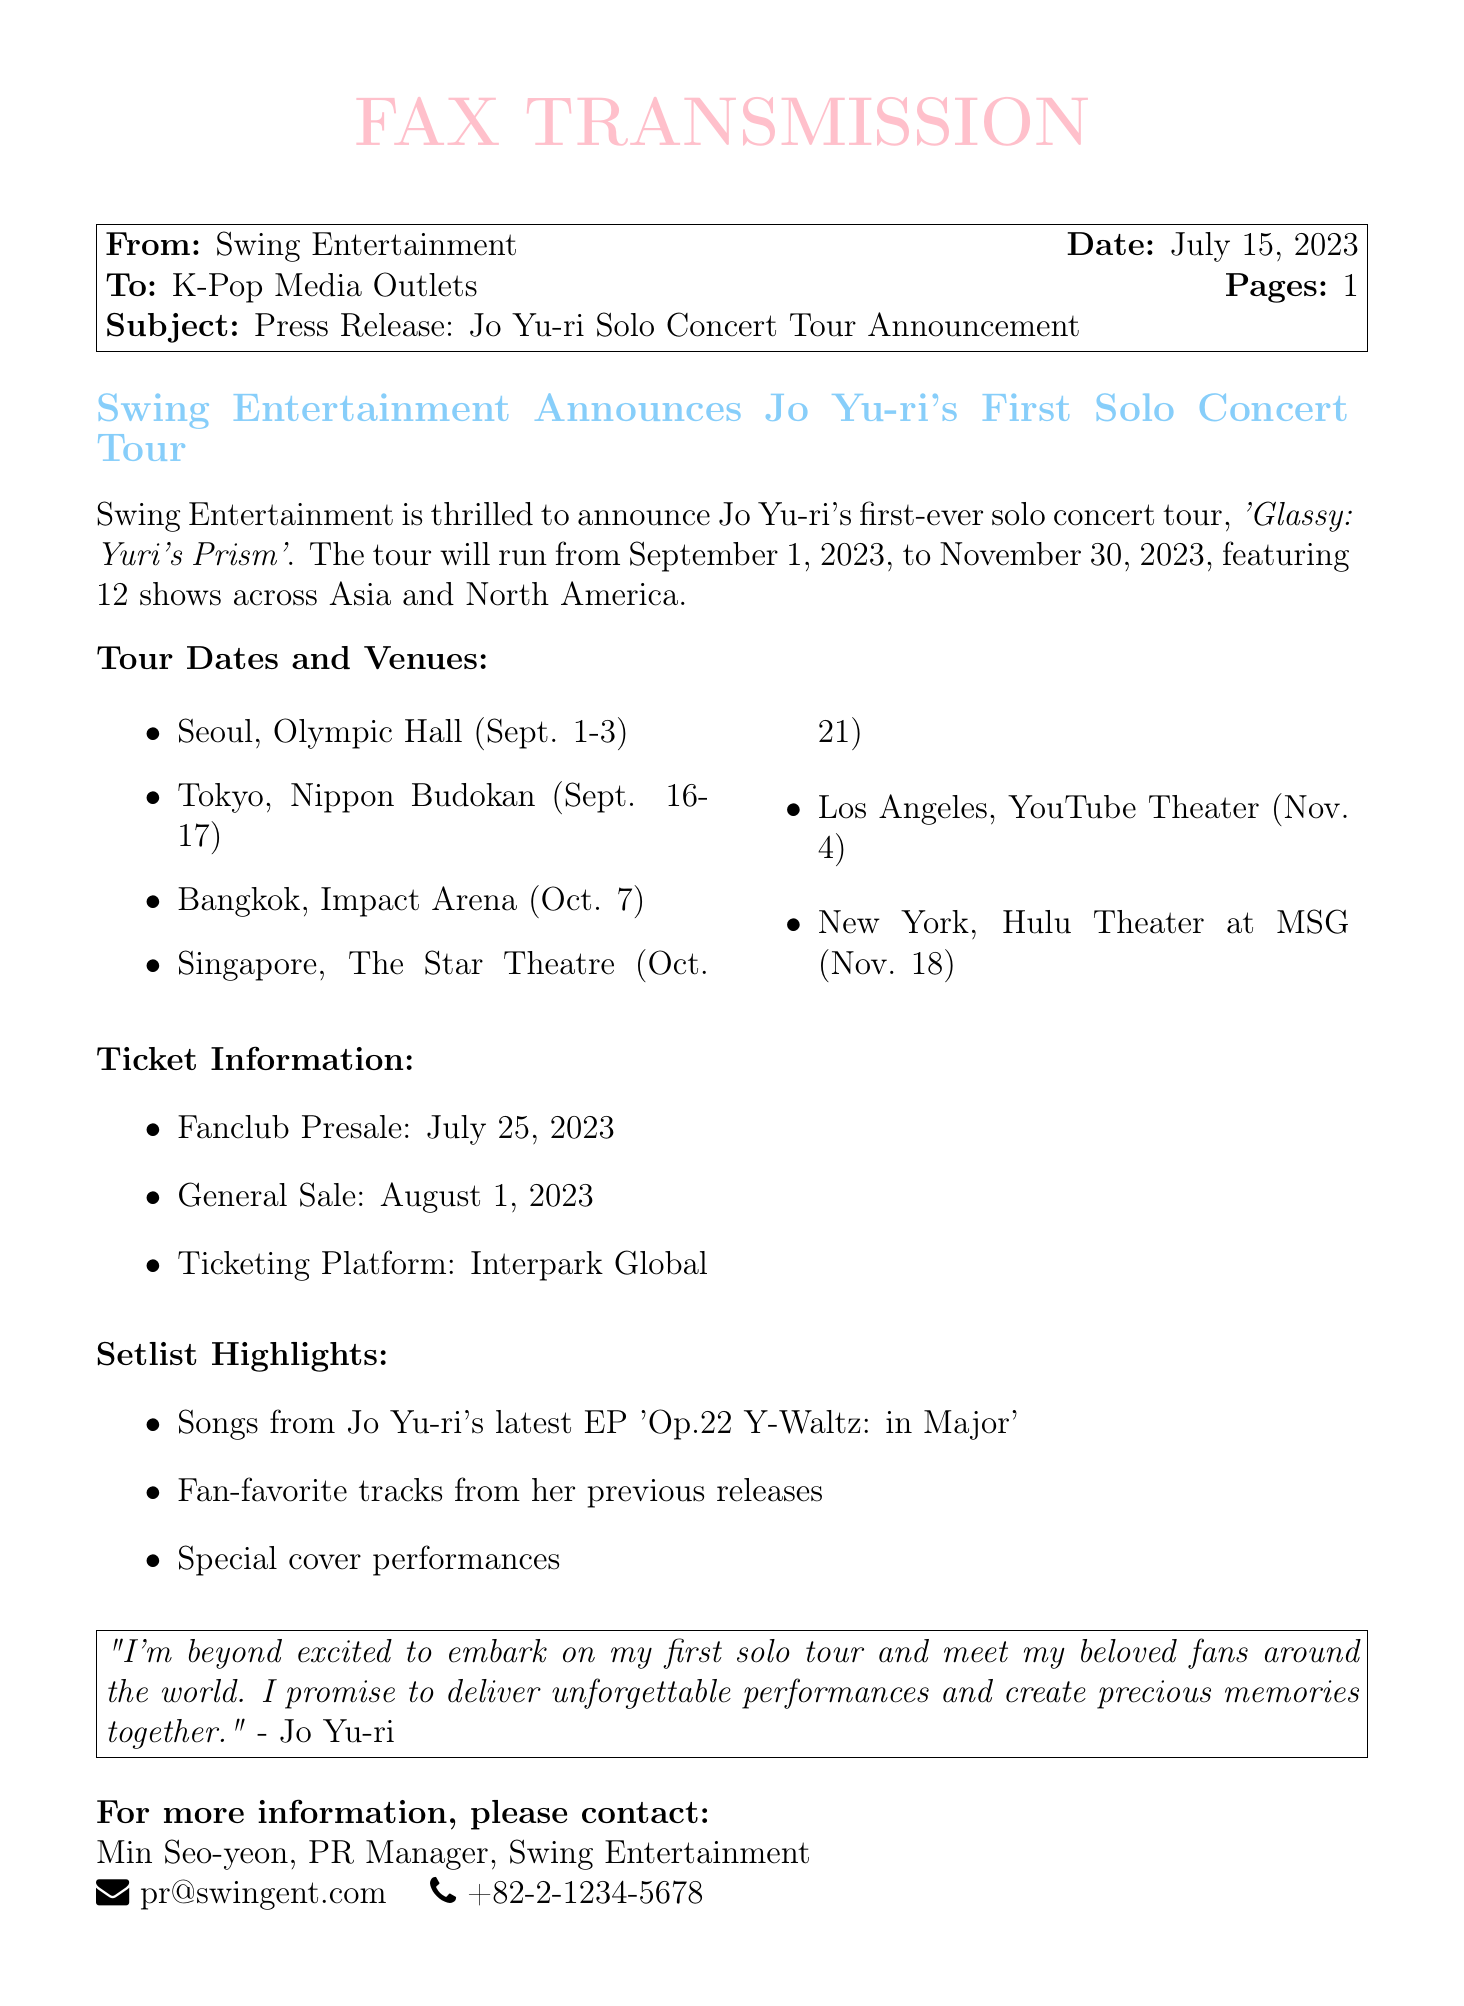What is the name of the concert tour? The document specifies that the concert tour is titled 'Glassy: Yuri's Prism'.
Answer: 'Glassy: Yuri's Prism' When does the tour start? The tour is set to begin on September 1, 2023, as stated in the document.
Answer: September 1, 2023 How many shows will be held during the tour? The document mentions that there will be a total of 12 shows across Asia and North America.
Answer: 12 What is the venue for the Seoul concert? The document states that the Seoul concerts will take place at Olympic Hall.
Answer: Olympic Hall What date will tickets go on general sale? According to the document, general sale will begin on August 1, 2023.
Answer: August 1, 2023 Who is the PR Manager for Swing Entertainment? The document identifies Min Seo-yeon as the PR Manager.
Answer: Min Seo-yeon What is included in the setlist highlights? The highlights mention songs from Jo Yu-ri's latest EP, fan-favorite tracks, and special cover performances.
Answer: Songs from Jo Yu-ri's latest EP 'Op.22 Y-Waltz: in Major', fan-favorite tracks, special cover performances How many days will the concerts in Tokyo take place? The document states that the Tokyo concerts will occur over two days, September 16-17, 2023.
Answer: 2 days 